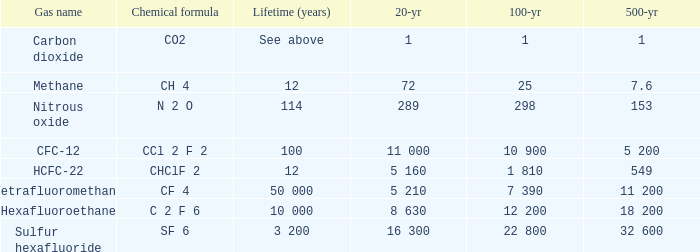What is the century-long duration for carbon dioxide? 1.0. 